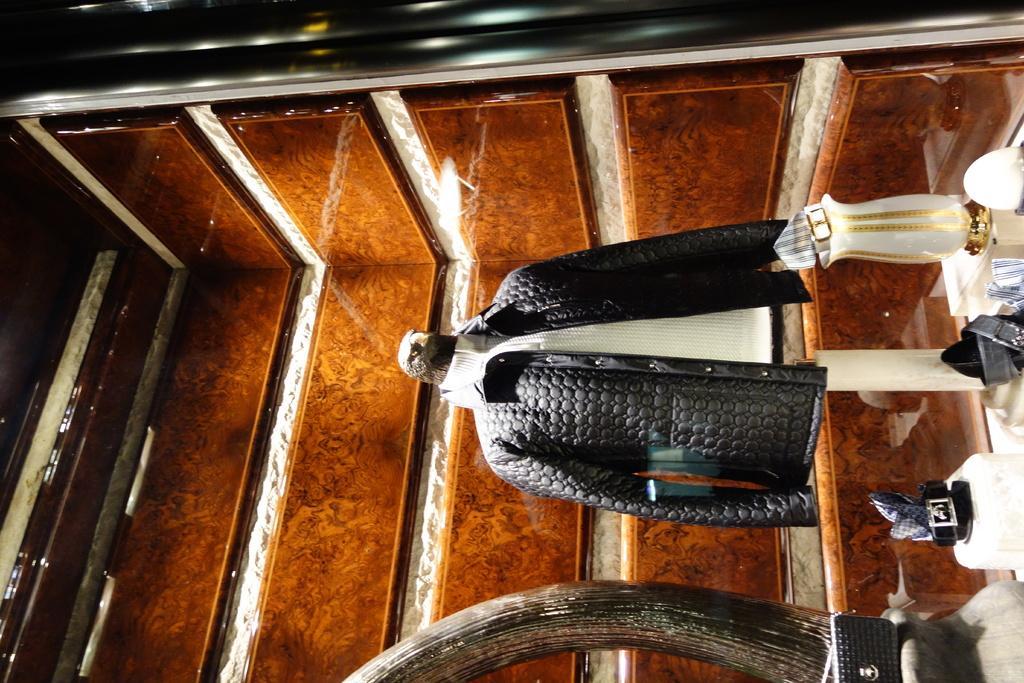In one or two sentences, can you explain what this image depicts? In this image we can see a jacket, belts and things. 